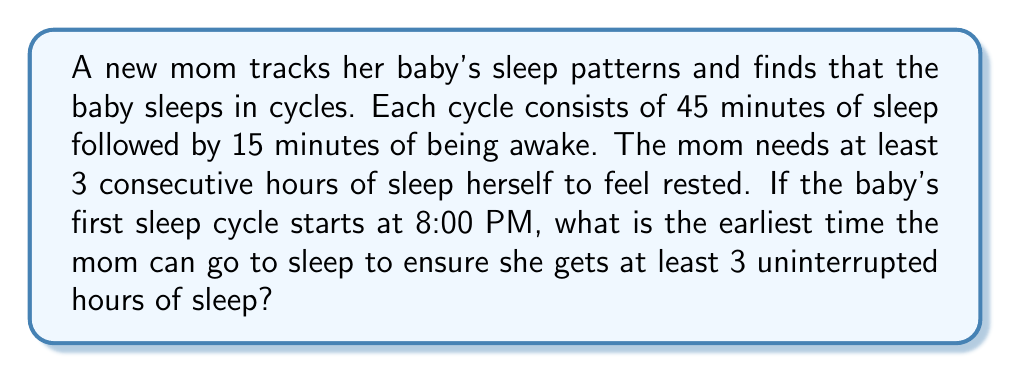Can you answer this question? Let's approach this step-by-step:

1) First, we need to understand the baby's sleep cycle:
   $$\text{Sleep cycle} = 45 \text{ minutes sleep} + 15 \text{ minutes awake} = 60 \text{ minutes}$$

2) The mom needs 3 consecutive hours (180 minutes) of sleep. This means we need to find a period where the baby sleeps for at least 3 hours straight.

3) Let's calculate how many full sleep cycles fit within 3 hours:
   $$\frac{180 \text{ minutes}}{60 \text{ minutes per cycle}} = 3 \text{ cycles}$$

4) Three full cycles would give:
   $$3 \times 45 \text{ minutes} = 135 \text{ minutes of sleep}$$

5) This is not enough for the mom's 3 hours. We need one more sleep cycle:
   $$4 \times 45 \text{ minutes} = 180 \text{ minutes of sleep}$$

6) So, we need to wait for 4 full cycles to pass before the mom can start her sleep.

7) Four cycles take:
   $$4 \times 60 \text{ minutes} = 240 \text{ minutes} = 4 \text{ hours}$$

8) The baby's first cycle starts at 8:00 PM. Adding 4 hours:
   $$8:00 \text{ PM} + 4 \text{ hours} = 12:00 \text{ AM (midnight)}$$

Therefore, the earliest time the mom can go to sleep to ensure 3 uninterrupted hours is 12:00 AM (midnight).
Answer: 12:00 AM (midnight) 